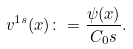Convert formula to latex. <formula><loc_0><loc_0><loc_500><loc_500>v ^ { 1 s } ( x ) \colon = \frac { \psi ( x ) } { C _ { 0 } s } .</formula> 